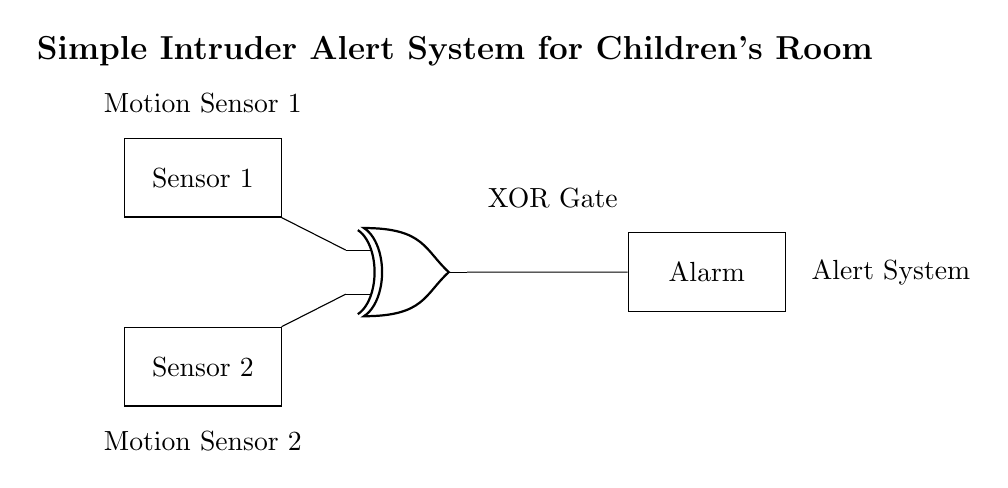What types of sensors are used in this circuit? The circuit includes two motion sensors: Sensor 1 and Sensor 2, both designed to detect movement in the room.
Answer: Motion sensors What is the function of the XOR gate in this system? The XOR gate outputs a signal indicating an alert only when one of the sensors detects motion, but not both simultaneously, ensuring the alarm is triggered only under specific conditions.
Answer: To determine motion How many devices are used to generate an alert? An alarm device is connected at the end of the circuit to provide an alert signal when the XOR gate conditions are met.
Answer: One device What connecting element is used between the motion sensors and the XOR gate? The connecting element is wires that transmit the motion signals from both sensors to the input terminals of the XOR gate, facilitating the logic operation.
Answer: Wires What happens when both sensors detect motion simultaneously? If both sensors detect motion, the XOR gate will output no alert because its condition requires only one sensor to be activated at a time for an alarm to sound.
Answer: No alert How many inputs does the XOR gate have in this circuit? The XOR gate has two inputs, which correspond to the outputs of Sensor 1 and Sensor 2, allowing it to evaluate the motion detection from both sensors.
Answer: Two inputs 